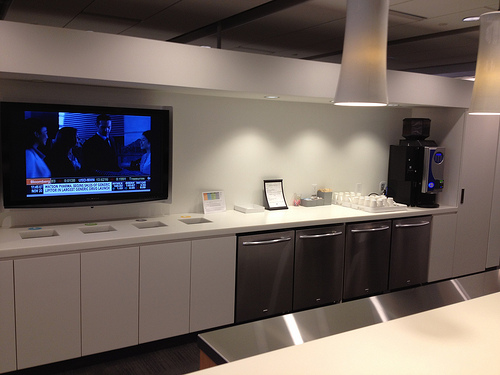Please provide a short description for this region: [0.74, 0.37, 0.94, 0.57]. This region contains a black coffee dispenser. 